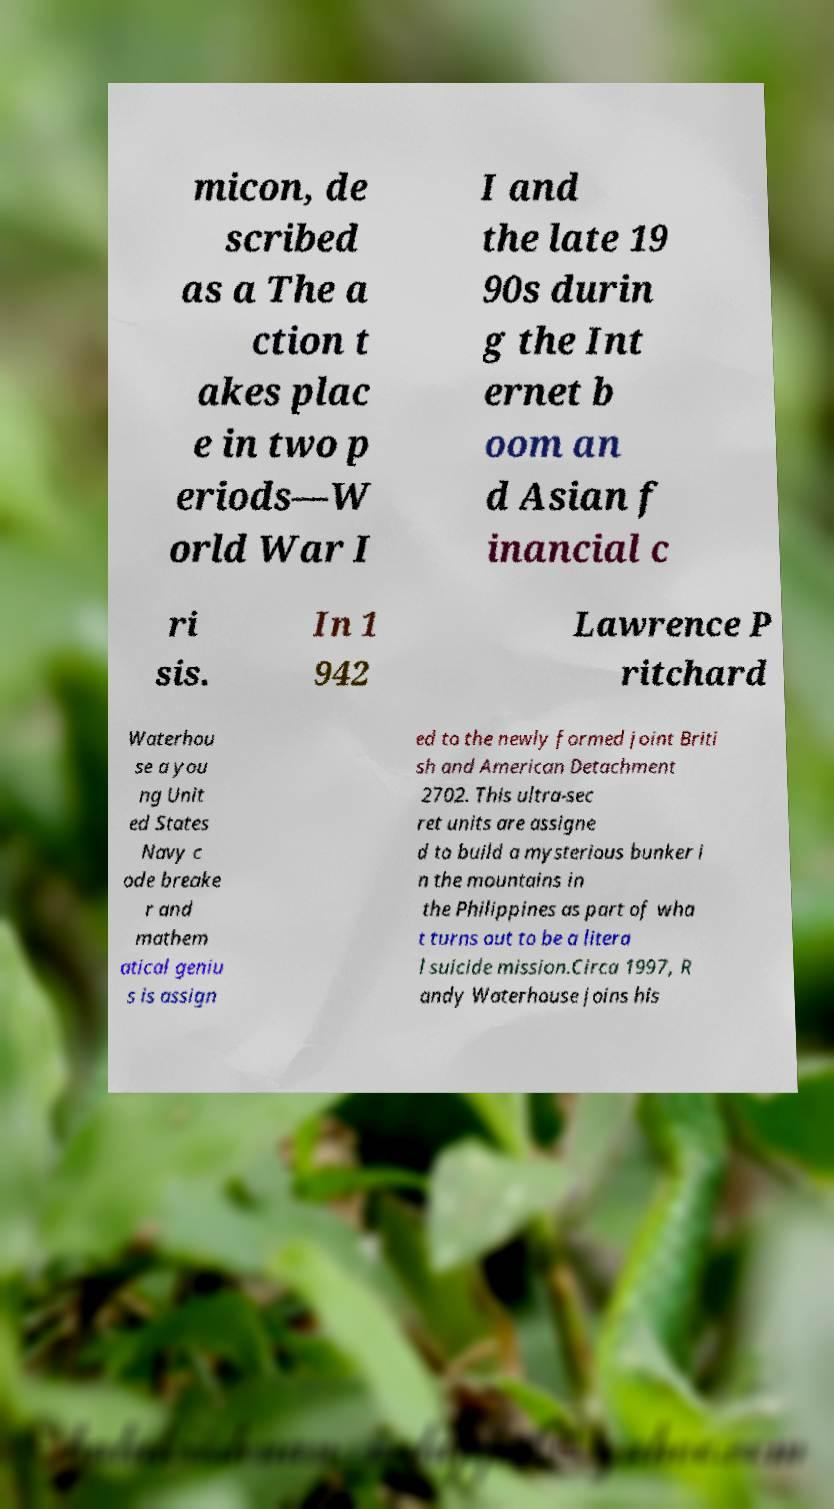Could you assist in decoding the text presented in this image and type it out clearly? micon, de scribed as a The a ction t akes plac e in two p eriods—W orld War I I and the late 19 90s durin g the Int ernet b oom an d Asian f inancial c ri sis. In 1 942 Lawrence P ritchard Waterhou se a you ng Unit ed States Navy c ode breake r and mathem atical geniu s is assign ed to the newly formed joint Briti sh and American Detachment 2702. This ultra-sec ret units are assigne d to build a mysterious bunker i n the mountains in the Philippines as part of wha t turns out to be a litera l suicide mission.Circa 1997, R andy Waterhouse joins his 